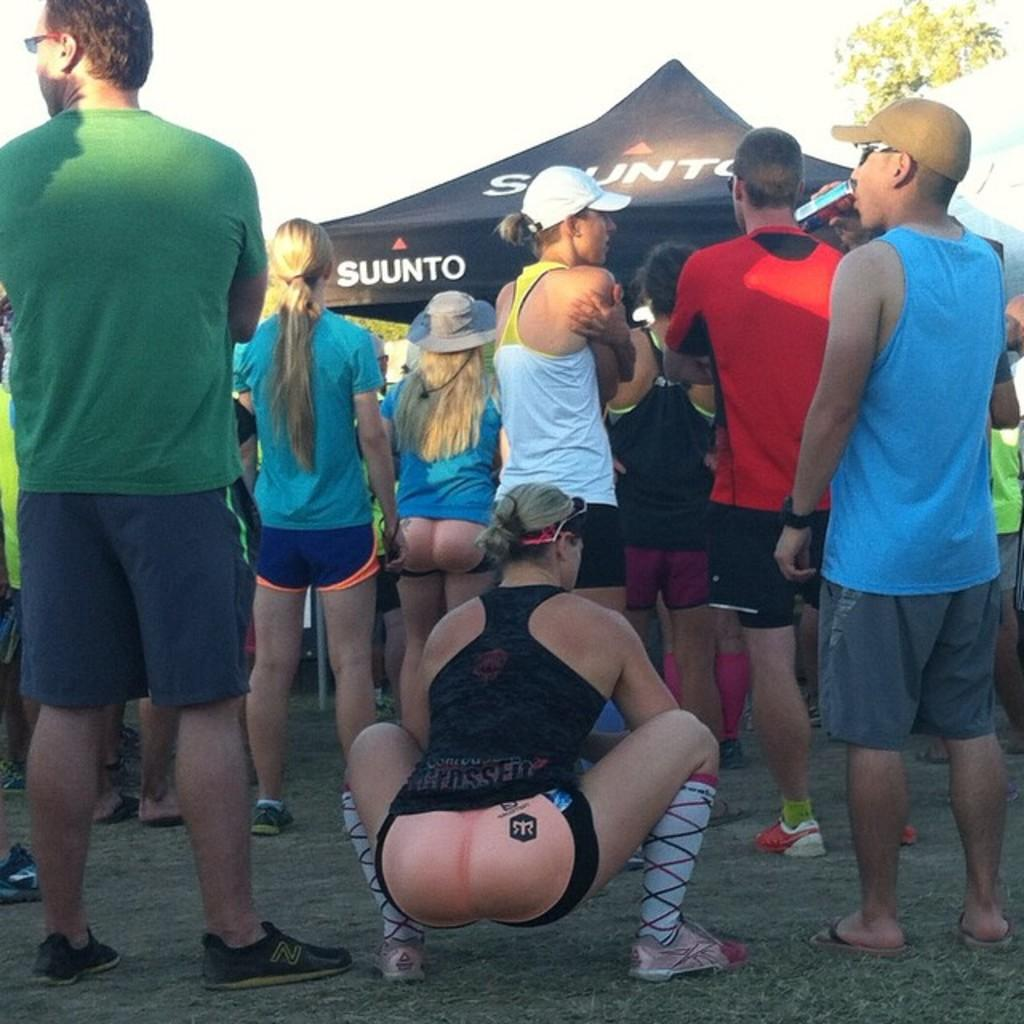<image>
Relay a brief, clear account of the picture shown. People standing in front of a tent that says SUUNTO on it. 